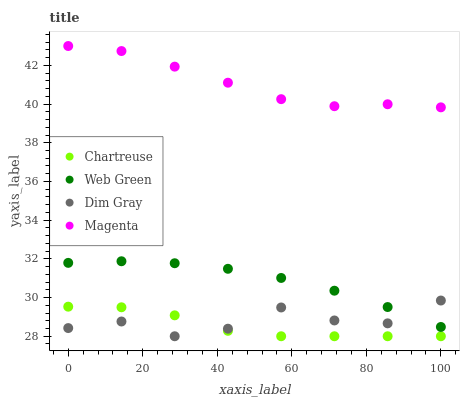Does Chartreuse have the minimum area under the curve?
Answer yes or no. Yes. Does Magenta have the maximum area under the curve?
Answer yes or no. Yes. Does Dim Gray have the minimum area under the curve?
Answer yes or no. No. Does Dim Gray have the maximum area under the curve?
Answer yes or no. No. Is Web Green the smoothest?
Answer yes or no. Yes. Is Dim Gray the roughest?
Answer yes or no. Yes. Is Magenta the smoothest?
Answer yes or no. No. Is Magenta the roughest?
Answer yes or no. No. Does Chartreuse have the lowest value?
Answer yes or no. Yes. Does Magenta have the lowest value?
Answer yes or no. No. Does Magenta have the highest value?
Answer yes or no. Yes. Does Dim Gray have the highest value?
Answer yes or no. No. Is Chartreuse less than Magenta?
Answer yes or no. Yes. Is Web Green greater than Chartreuse?
Answer yes or no. Yes. Does Web Green intersect Dim Gray?
Answer yes or no. Yes. Is Web Green less than Dim Gray?
Answer yes or no. No. Is Web Green greater than Dim Gray?
Answer yes or no. No. Does Chartreuse intersect Magenta?
Answer yes or no. No. 